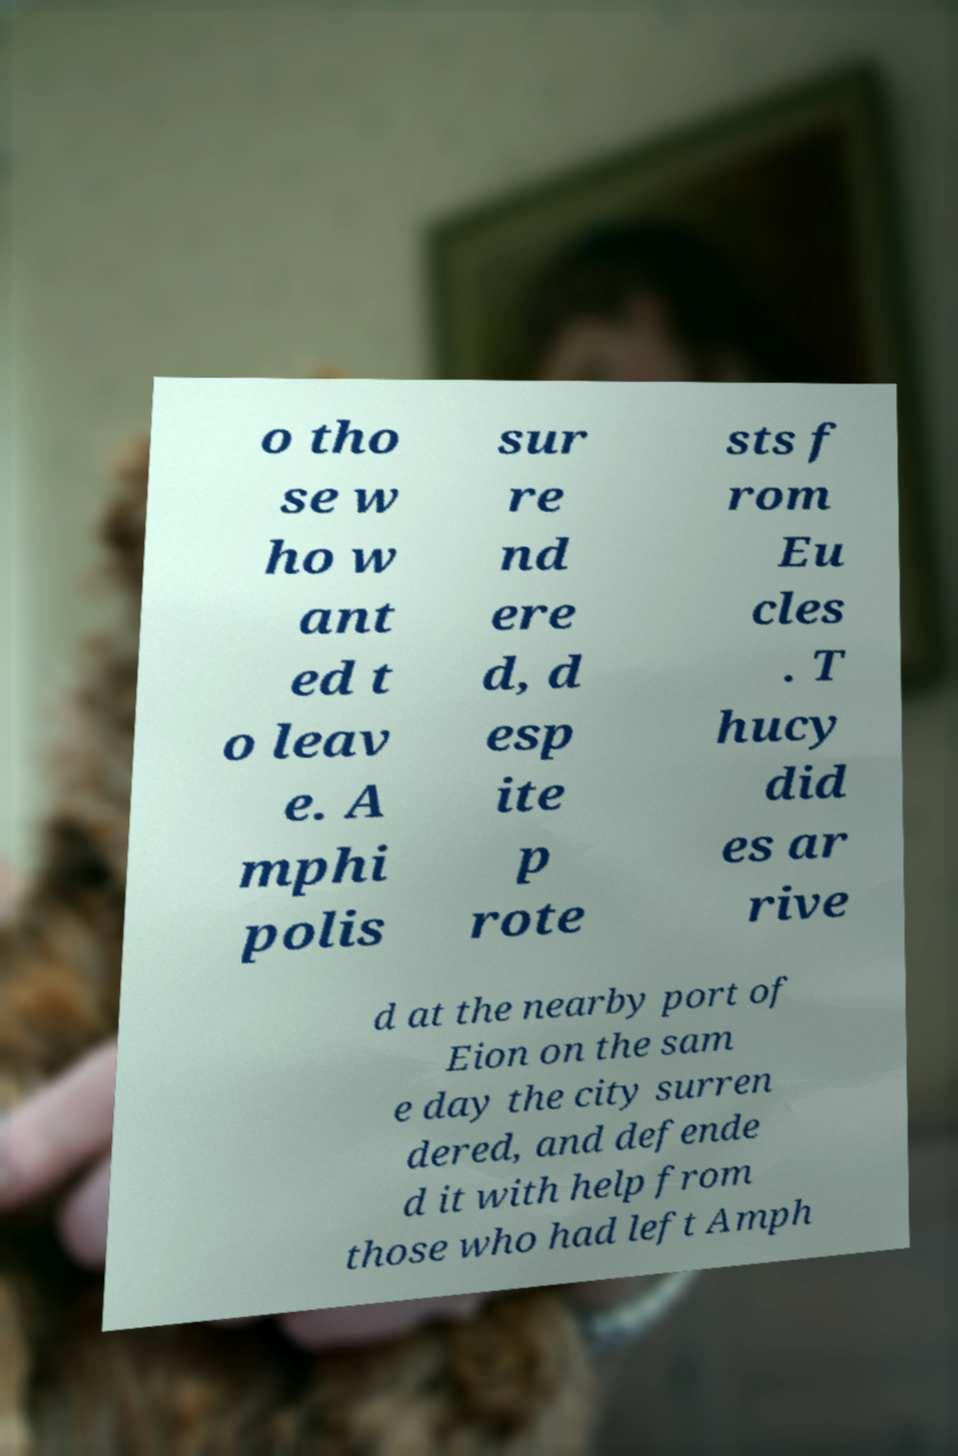Please read and relay the text visible in this image. What does it say? o tho se w ho w ant ed t o leav e. A mphi polis sur re nd ere d, d esp ite p rote sts f rom Eu cles . T hucy did es ar rive d at the nearby port of Eion on the sam e day the city surren dered, and defende d it with help from those who had left Amph 